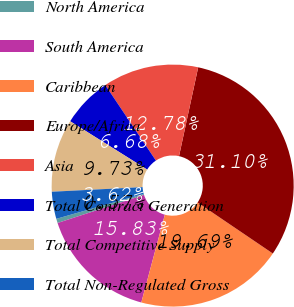Convert chart. <chart><loc_0><loc_0><loc_500><loc_500><pie_chart><fcel>North America<fcel>South America<fcel>Caribbean<fcel>Europe/Africa<fcel>Asia<fcel>Total Contract Generation<fcel>Total Competitive Supply<fcel>Total Non-Regulated Gross<nl><fcel>0.57%<fcel>15.83%<fcel>19.69%<fcel>31.1%<fcel>12.78%<fcel>6.68%<fcel>9.73%<fcel>3.62%<nl></chart> 